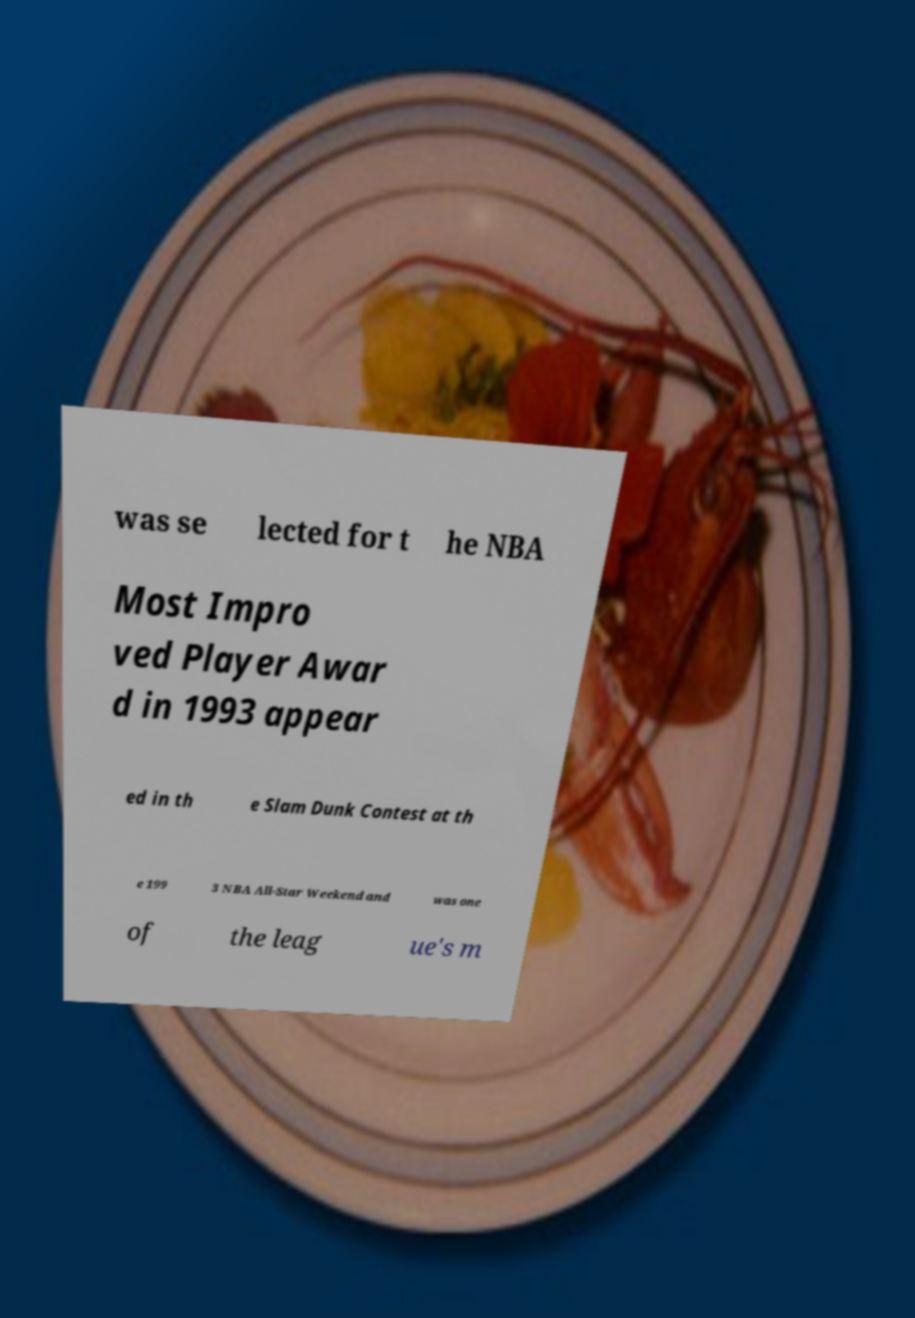What messages or text are displayed in this image? I need them in a readable, typed format. was se lected for t he NBA Most Impro ved Player Awar d in 1993 appear ed in th e Slam Dunk Contest at th e 199 3 NBA All-Star Weekend and was one of the leag ue's m 